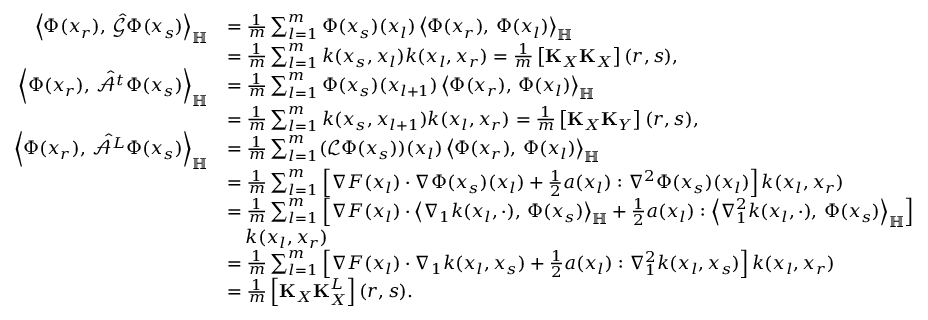<formula> <loc_0><loc_0><loc_500><loc_500>\begin{array} { r l } { \left \langle \Phi ( x _ { r } ) , \, \hat { \mathcal { G } } \Phi ( x _ { s } ) \right \rangle _ { \mathbb { H } } } & { = \frac { 1 } { m } \sum _ { l = 1 } ^ { m } \Phi ( x _ { s } ) ( x _ { l } ) \left \langle \Phi ( x _ { r } ) , \, \Phi ( x _ { l } ) \right \rangle _ { \mathbb { H } } } \\ & { = \frac { 1 } { m } \sum _ { l = 1 } ^ { m } k ( x _ { s } , x _ { l } ) k ( x _ { l } , x _ { r } ) = \frac { 1 } { m } \left [ K _ { X } K _ { X } \right ] ( r , s ) , } \\ { \left \langle \Phi ( x _ { r } ) , \, \hat { \mathcal { A } ^ { t } } \Phi ( x _ { s } ) \right \rangle _ { \mathbb { H } } } & { = \frac { 1 } { m } \sum _ { l = 1 } ^ { m } \Phi ( x _ { s } ) ( x _ { l + 1 } ) \left \langle \Phi ( x _ { r } ) , \, \Phi ( x _ { l } ) \right \rangle _ { \mathbb { H } } } \\ & { = \frac { 1 } { m } \sum _ { l = 1 } ^ { m } k ( x _ { s } , x _ { l + 1 } ) k ( x _ { l } , x _ { r } ) = \frac { 1 } { m } \left [ K _ { X } K _ { Y } \right ] ( r , s ) , } \\ { \left \langle \Phi ( x _ { r } ) , \, \hat { \mathcal { A } ^ { L } } \Phi ( x _ { s } ) \right \rangle _ { \mathbb { H } } } & { = \frac { 1 } { m } \sum _ { l = 1 } ^ { m } ( \mathcal { L } \Phi ( x _ { s } ) ) ( x _ { l } ) \left \langle \Phi ( x _ { r } ) , \, \Phi ( x _ { l } ) \right \rangle _ { \mathbb { H } } } \\ & { = \frac { 1 } { m } \sum _ { l = 1 } ^ { m } \left [ \nabla F ( x _ { l } ) \cdot \nabla \Phi ( x _ { s } ) ( x _ { l } ) + \frac { 1 } { 2 } a ( x _ { l } ) \colon \nabla ^ { 2 } \Phi ( x _ { s } ) ( x _ { l } ) \right ] k ( x _ { l } , x _ { r } ) } \\ & { = \frac { 1 } { m } \sum _ { l = 1 } ^ { m } \left [ \nabla F ( x _ { l } ) \cdot \left \langle \nabla _ { 1 } k ( x _ { l } , \cdot ) , \, \Phi ( x _ { s } ) \right \rangle _ { \mathbb { H } } + \frac { 1 } { 2 } a ( x _ { l } ) \colon \left \langle \nabla _ { 1 } ^ { 2 } k ( x _ { l } , \cdot ) , \, \Phi ( x _ { s } ) \right \rangle _ { \mathbb { H } } \right ] } \\ & { \quad k ( x _ { l } , x _ { r } ) } \\ & { = \frac { 1 } { m } \sum _ { l = 1 } ^ { m } \left [ \nabla F ( x _ { l } ) \cdot \nabla _ { 1 } k ( x _ { l } , x _ { s } ) + \frac { 1 } { 2 } a ( x _ { l } ) \colon \nabla _ { 1 } ^ { 2 } k ( x _ { l } , x _ { s } ) \right ] k ( x _ { l } , x _ { r } ) } \\ & { = \frac { 1 } { m } \left [ K _ { X } K _ { X } ^ { L } \right ] ( r , s ) . } \end{array}</formula> 